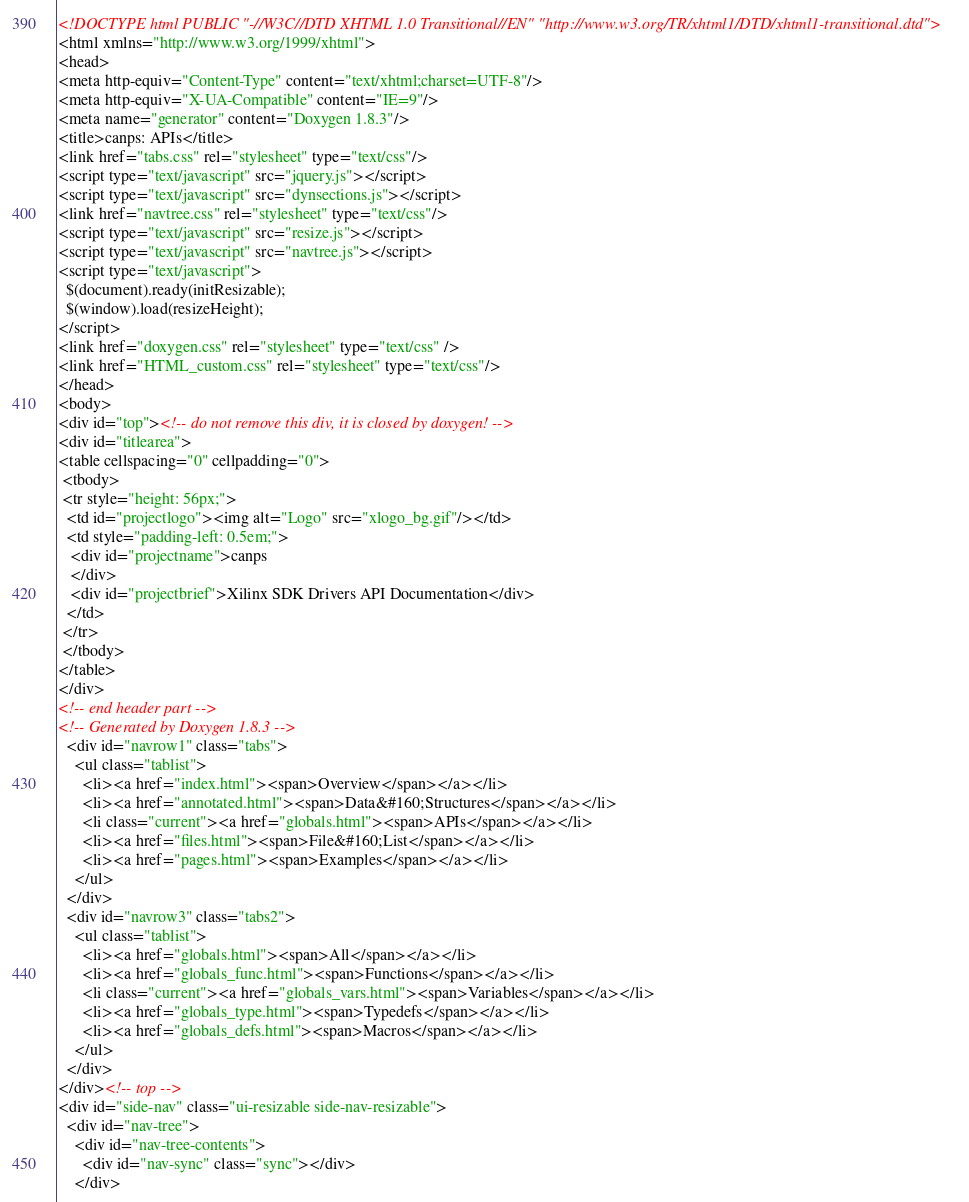Convert code to text. <code><loc_0><loc_0><loc_500><loc_500><_HTML_><!DOCTYPE html PUBLIC "-//W3C//DTD XHTML 1.0 Transitional//EN" "http://www.w3.org/TR/xhtml1/DTD/xhtml1-transitional.dtd">
<html xmlns="http://www.w3.org/1999/xhtml">
<head>
<meta http-equiv="Content-Type" content="text/xhtml;charset=UTF-8"/>
<meta http-equiv="X-UA-Compatible" content="IE=9"/>
<meta name="generator" content="Doxygen 1.8.3"/>
<title>canps: APIs</title>
<link href="tabs.css" rel="stylesheet" type="text/css"/>
<script type="text/javascript" src="jquery.js"></script>
<script type="text/javascript" src="dynsections.js"></script>
<link href="navtree.css" rel="stylesheet" type="text/css"/>
<script type="text/javascript" src="resize.js"></script>
<script type="text/javascript" src="navtree.js"></script>
<script type="text/javascript">
  $(document).ready(initResizable);
  $(window).load(resizeHeight);
</script>
<link href="doxygen.css" rel="stylesheet" type="text/css" />
<link href="HTML_custom.css" rel="stylesheet" type="text/css"/>
</head>
<body>
<div id="top"><!-- do not remove this div, it is closed by doxygen! -->
<div id="titlearea">
<table cellspacing="0" cellpadding="0">
 <tbody>
 <tr style="height: 56px;">
  <td id="projectlogo"><img alt="Logo" src="xlogo_bg.gif"/></td>
  <td style="padding-left: 0.5em;">
   <div id="projectname">canps
   </div>
   <div id="projectbrief">Xilinx SDK Drivers API Documentation</div>
  </td>
 </tr>
 </tbody>
</table>
</div>
<!-- end header part -->
<!-- Generated by Doxygen 1.8.3 -->
  <div id="navrow1" class="tabs">
    <ul class="tablist">
      <li><a href="index.html"><span>Overview</span></a></li>
      <li><a href="annotated.html"><span>Data&#160;Structures</span></a></li>
      <li class="current"><a href="globals.html"><span>APIs</span></a></li>
      <li><a href="files.html"><span>File&#160;List</span></a></li>
      <li><a href="pages.html"><span>Examples</span></a></li>
    </ul>
  </div>
  <div id="navrow3" class="tabs2">
    <ul class="tablist">
      <li><a href="globals.html"><span>All</span></a></li>
      <li><a href="globals_func.html"><span>Functions</span></a></li>
      <li class="current"><a href="globals_vars.html"><span>Variables</span></a></li>
      <li><a href="globals_type.html"><span>Typedefs</span></a></li>
      <li><a href="globals_defs.html"><span>Macros</span></a></li>
    </ul>
  </div>
</div><!-- top -->
<div id="side-nav" class="ui-resizable side-nav-resizable">
  <div id="nav-tree">
    <div id="nav-tree-contents">
      <div id="nav-sync" class="sync"></div>
    </div></code> 